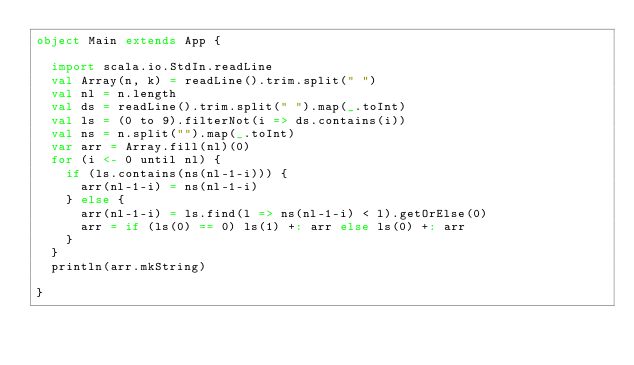Convert code to text. <code><loc_0><loc_0><loc_500><loc_500><_Scala_>object Main extends App {

  import scala.io.StdIn.readLine
  val Array(n, k) = readLine().trim.split(" ")
  val nl = n.length
  val ds = readLine().trim.split(" ").map(_.toInt)
  val ls = (0 to 9).filterNot(i => ds.contains(i))
  val ns = n.split("").map(_.toInt)
  var arr = Array.fill(nl)(0)
  for (i <- 0 until nl) {
    if (ls.contains(ns(nl-1-i))) {
      arr(nl-1-i) = ns(nl-1-i)
    } else {
      arr(nl-1-i) = ls.find(l => ns(nl-1-i) < l).getOrElse(0)
      arr = if (ls(0) == 0) ls(1) +: arr else ls(0) +: arr
    }
  }
  println(arr.mkString)

}
</code> 